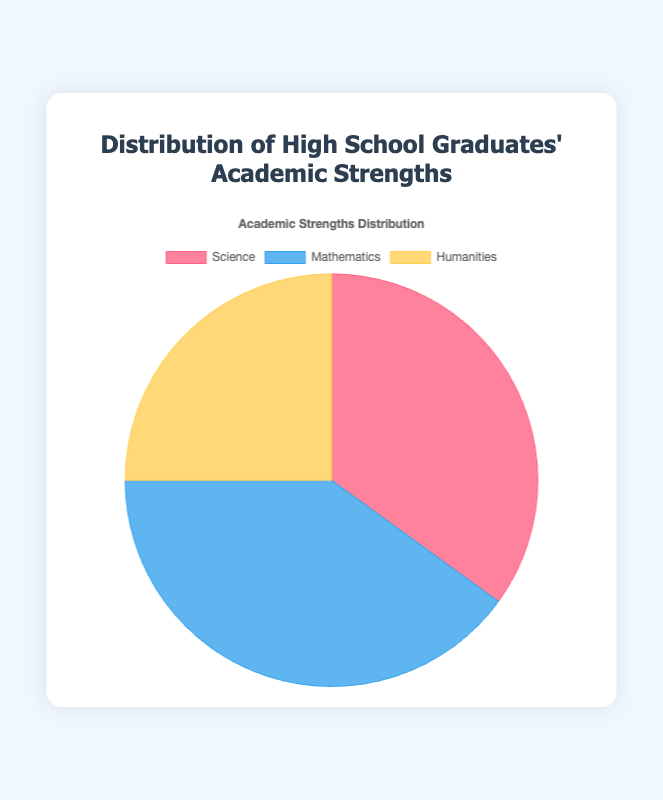What is the percentage of high school graduates with a strength in Science? The figure shows three categories with their respective percentages, and Science is 35%.
Answer: 35% Which academic strength has the highest percentage? By comparing the percentages for Science (35%), Mathematics (40%), and Humanities (25%), Mathematics has the highest percentage.
Answer: Mathematics What is the combined percentage of graduates strong in Science and Humanities? Adding the Science percentage (35%) to the Humanities percentage (25%) gives 35% + 25% = 60%.
Answer: 60% How much greater is the percentage of students strong in Mathematics compared to those in Humanities? The Mathematics percentage is 40% and Humanities is 25%. The difference is 40% - 25% = 15%.
Answer: 15% What is the color associated with the Humanities category? The visual representation shows different colors for each category, and Humanities is represented by yellow.
Answer: Yellow If the pie chart represents 100 graduates, how many are strong in Mathematics? 40% of 100 graduates are strong in Mathematics, so 0.4 * 100 = 40 graduates.
Answer: 40 What is the average percentage of graduates across all three categories? Sum the percentages (35% + 40% + 25%) = 100%, divide by 3, so the average is 100% / 3 ≈ 33.33%.
Answer: 33.33% Which categories have a higher percentage than Humanities? Both Science (35%) and Mathematics (40%) have percentages higher than Humanities (25%).
Answer: Science and Mathematics What fraction of the total percentage does the Science category represent? Science represents 35% out of 100%, so the fraction is 35/100 which simplifies to 7/20.
Answer: 7/20 Between Science and Mathematics, which category has a smaller percentage, and by how much? Science has 35%, Mathematics has 40%. Mathematics is 40% - 35% = 5% greater than Science.
Answer: Science, 5% 